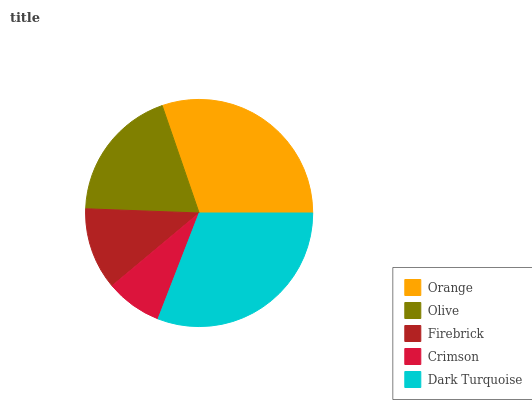Is Crimson the minimum?
Answer yes or no. Yes. Is Dark Turquoise the maximum?
Answer yes or no. Yes. Is Olive the minimum?
Answer yes or no. No. Is Olive the maximum?
Answer yes or no. No. Is Orange greater than Olive?
Answer yes or no. Yes. Is Olive less than Orange?
Answer yes or no. Yes. Is Olive greater than Orange?
Answer yes or no. No. Is Orange less than Olive?
Answer yes or no. No. Is Olive the high median?
Answer yes or no. Yes. Is Olive the low median?
Answer yes or no. Yes. Is Orange the high median?
Answer yes or no. No. Is Firebrick the low median?
Answer yes or no. No. 